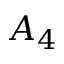Convert formula to latex. <formula><loc_0><loc_0><loc_500><loc_500>A _ { 4 }</formula> 